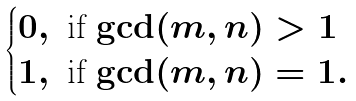Convert formula to latex. <formula><loc_0><loc_0><loc_500><loc_500>\begin{cases} 0 , \ \text {if $\gcd(m,n) >1$} \\ 1 , \ \text {if $\gcd(m,n) =1$} . \end{cases}</formula> 